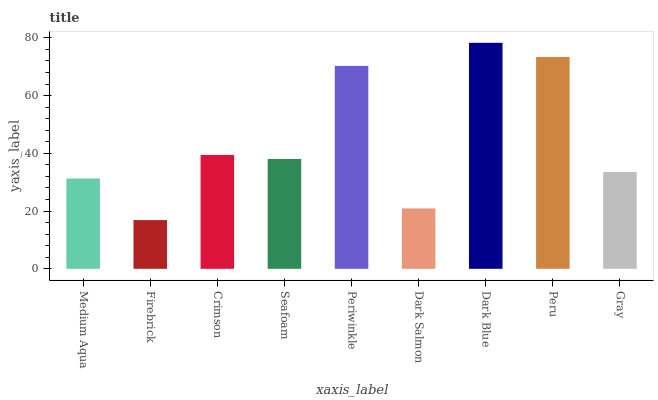Is Firebrick the minimum?
Answer yes or no. Yes. Is Dark Blue the maximum?
Answer yes or no. Yes. Is Crimson the minimum?
Answer yes or no. No. Is Crimson the maximum?
Answer yes or no. No. Is Crimson greater than Firebrick?
Answer yes or no. Yes. Is Firebrick less than Crimson?
Answer yes or no. Yes. Is Firebrick greater than Crimson?
Answer yes or no. No. Is Crimson less than Firebrick?
Answer yes or no. No. Is Seafoam the high median?
Answer yes or no. Yes. Is Seafoam the low median?
Answer yes or no. Yes. Is Peru the high median?
Answer yes or no. No. Is Crimson the low median?
Answer yes or no. No. 